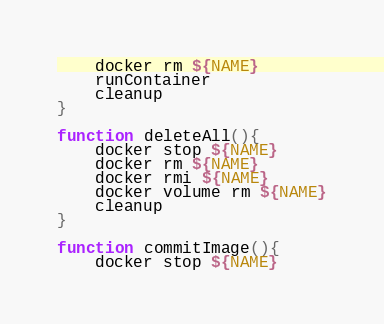<code> <loc_0><loc_0><loc_500><loc_500><_Bash_>    docker rm ${NAME}
    runContainer
    cleanup
}

function deleteAll(){
    docker stop ${NAME}
    docker rm ${NAME}
    docker rmi ${NAME}
    docker volume rm ${NAME}
    cleanup
}

function commitImage(){
    docker stop ${NAME}</code> 